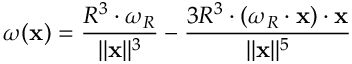<formula> <loc_0><loc_0><loc_500><loc_500>{ \omega } ( x ) = { \frac { R ^ { 3 } \cdot { \omega } _ { R } } { \| x \| ^ { 3 } } } - { \frac { 3 R ^ { 3 } \cdot ( { \omega } _ { R } \cdot x ) \cdot x } { \| x \| ^ { 5 } } }</formula> 